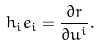Convert formula to latex. <formula><loc_0><loc_0><loc_500><loc_500>h _ { i } { e } _ { i } = \frac { \partial { r } } { \partial u ^ { i } } .</formula> 